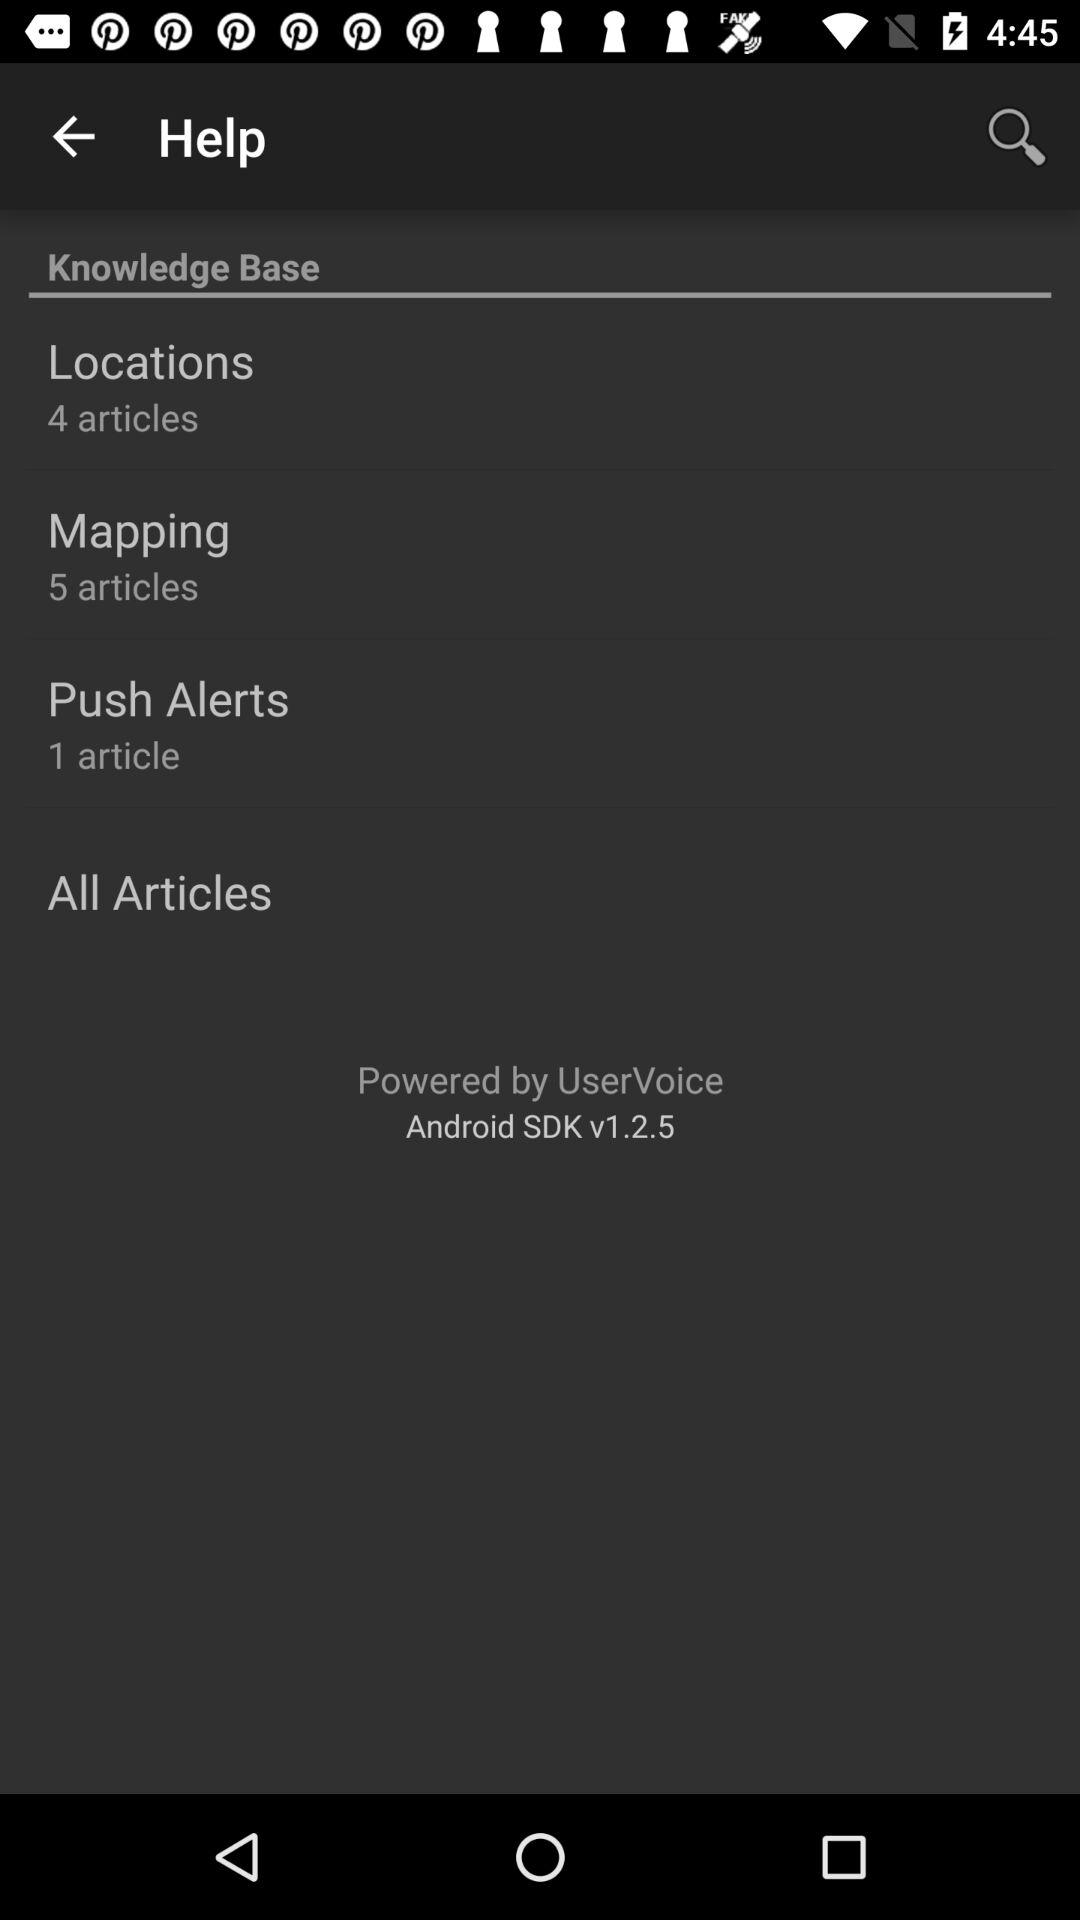What is the version? The version is v1.2.5. 